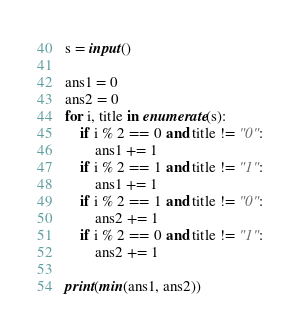Convert code to text. <code><loc_0><loc_0><loc_500><loc_500><_Python_>s = input()

ans1 = 0
ans2 = 0
for i, title in enumerate(s):
    if i % 2 == 0 and title != "0":
        ans1 += 1
    if i % 2 == 1 and title != "1":
        ans1 += 1
    if i % 2 == 1 and title != "0":
        ans2 += 1
    if i % 2 == 0 and title != "1":
        ans2 += 1

print(min(ans1, ans2))

</code> 